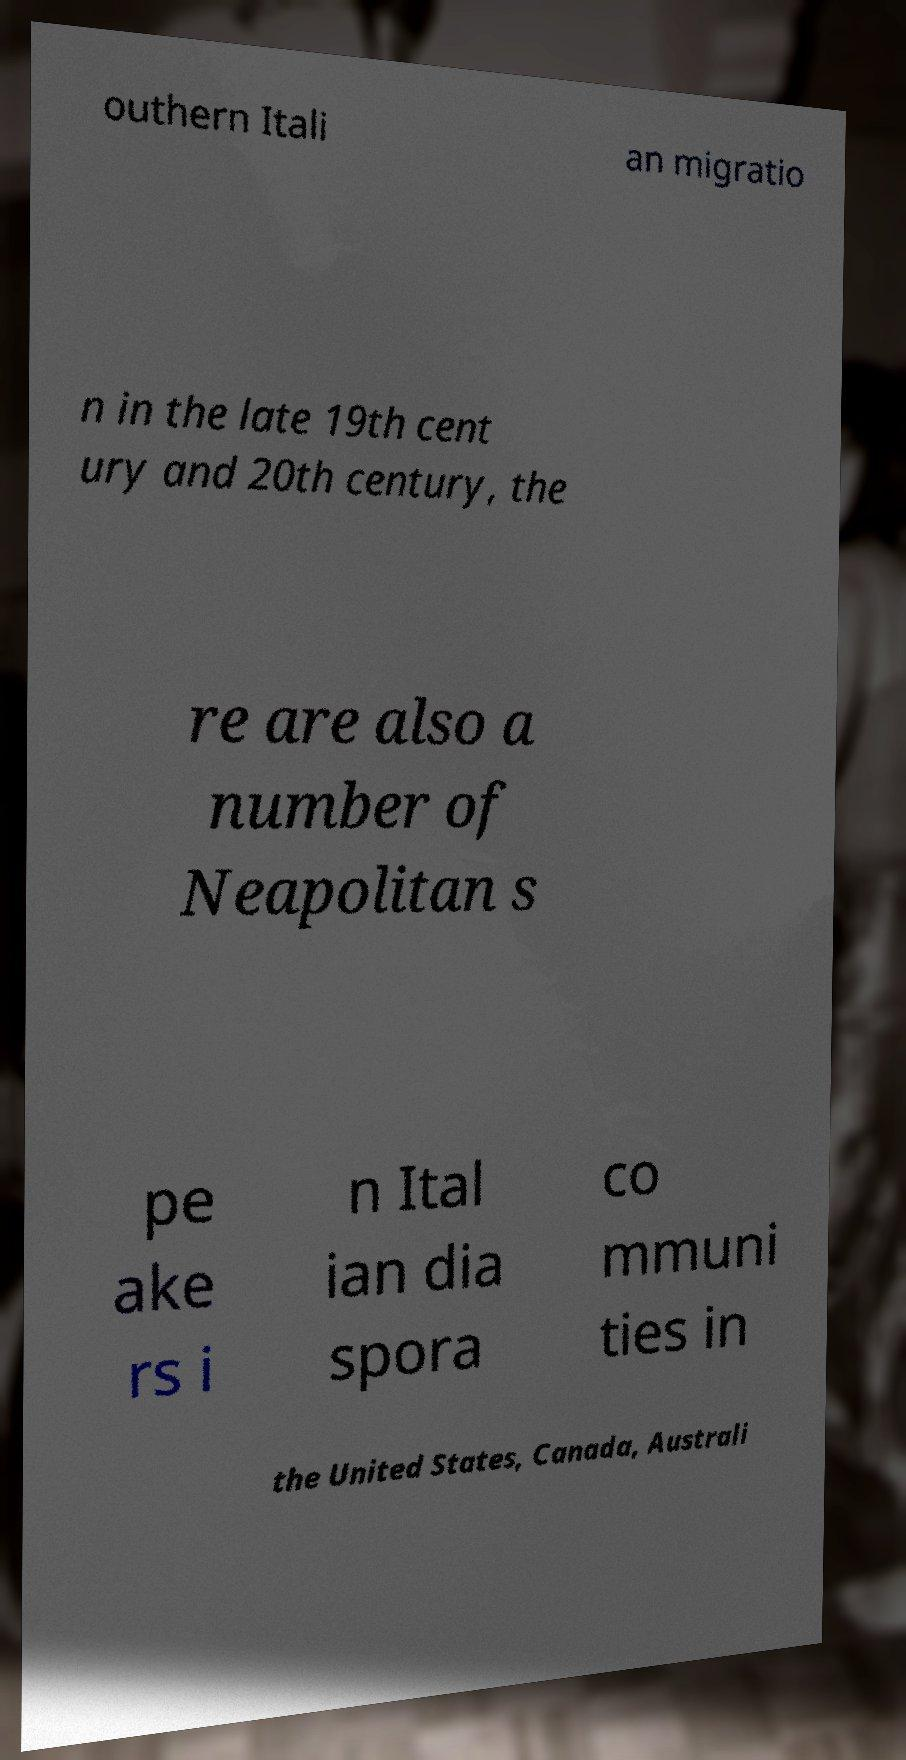There's text embedded in this image that I need extracted. Can you transcribe it verbatim? outhern Itali an migratio n in the late 19th cent ury and 20th century, the re are also a number of Neapolitan s pe ake rs i n Ital ian dia spora co mmuni ties in the United States, Canada, Australi 